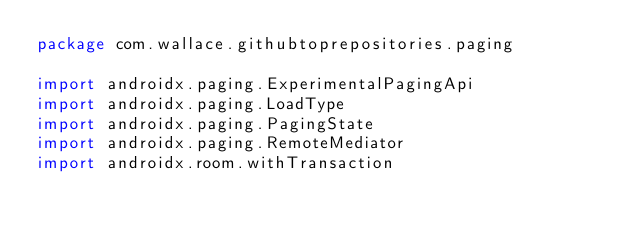Convert code to text. <code><loc_0><loc_0><loc_500><loc_500><_Kotlin_>package com.wallace.githubtoprepositories.paging

import androidx.paging.ExperimentalPagingApi
import androidx.paging.LoadType
import androidx.paging.PagingState
import androidx.paging.RemoteMediator
import androidx.room.withTransaction</code> 